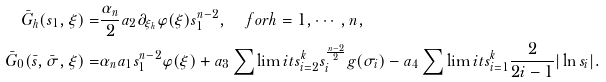<formula> <loc_0><loc_0><loc_500><loc_500>\bar { G } _ { h } ( s _ { 1 } , \xi ) = & \frac { \alpha _ { n } } { 2 } a _ { 2 } \partial _ { \xi _ { h } } \varphi ( \xi ) s _ { 1 } ^ { n - 2 } , \quad f o r h = 1 , \cdots , n , \\ \bar { G } _ { 0 } ( \bar { s } , \bar { \sigma } , \xi ) = & \alpha _ { n } a _ { 1 } s _ { 1 } ^ { n - 2 } \varphi ( \xi ) + a _ { 3 } \sum \lim i t s _ { i = 2 } ^ { k } s _ { i } ^ { \frac { n - 2 } { 2 } } g ( \sigma _ { i } ) - a _ { 4 } \sum \lim i t s _ { i = 1 } ^ { k } \frac { 2 } { 2 i - 1 } | \ln s _ { i } | .</formula> 